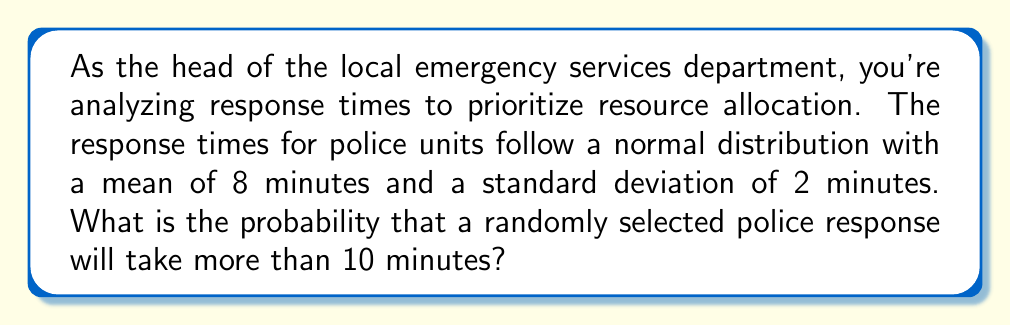Can you answer this question? To solve this problem, we need to use the properties of the normal distribution and the concept of z-scores.

1. Given information:
   - Response times follow a normal distribution
   - Mean (μ) = 8 minutes
   - Standard deviation (σ) = 2 minutes
   - We want to find P(X > 10), where X is the response time

2. Calculate the z-score for 10 minutes:
   $$z = \frac{x - \mu}{\sigma} = \frac{10 - 8}{2} = 1$$

3. Use the standard normal distribution table or a calculator to find the area to the right of z = 1:
   P(Z > 1) = 1 - P(Z < 1) = 1 - 0.8413 = 0.1587

4. Therefore, the probability of a response taking more than 10 minutes is approximately 0.1587 or 15.87%

This analysis can help inform decisions about resource allocation and the need for stricter performance standards in emergency services to ensure public safety.
Answer: The probability that a randomly selected police response will take more than 10 minutes is approximately 0.1587 or 15.87%. 